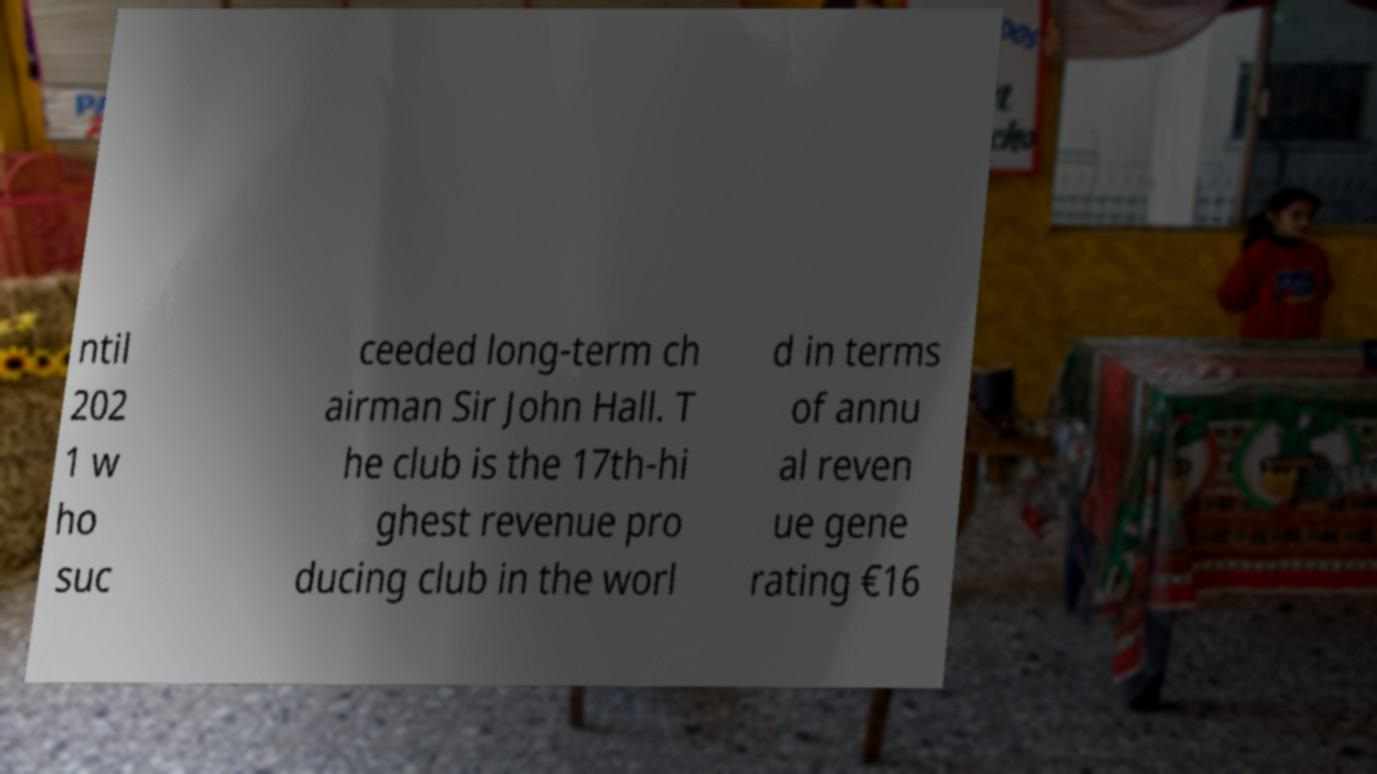I need the written content from this picture converted into text. Can you do that? ntil 202 1 w ho suc ceeded long-term ch airman Sir John Hall. T he club is the 17th-hi ghest revenue pro ducing club in the worl d in terms of annu al reven ue gene rating €16 